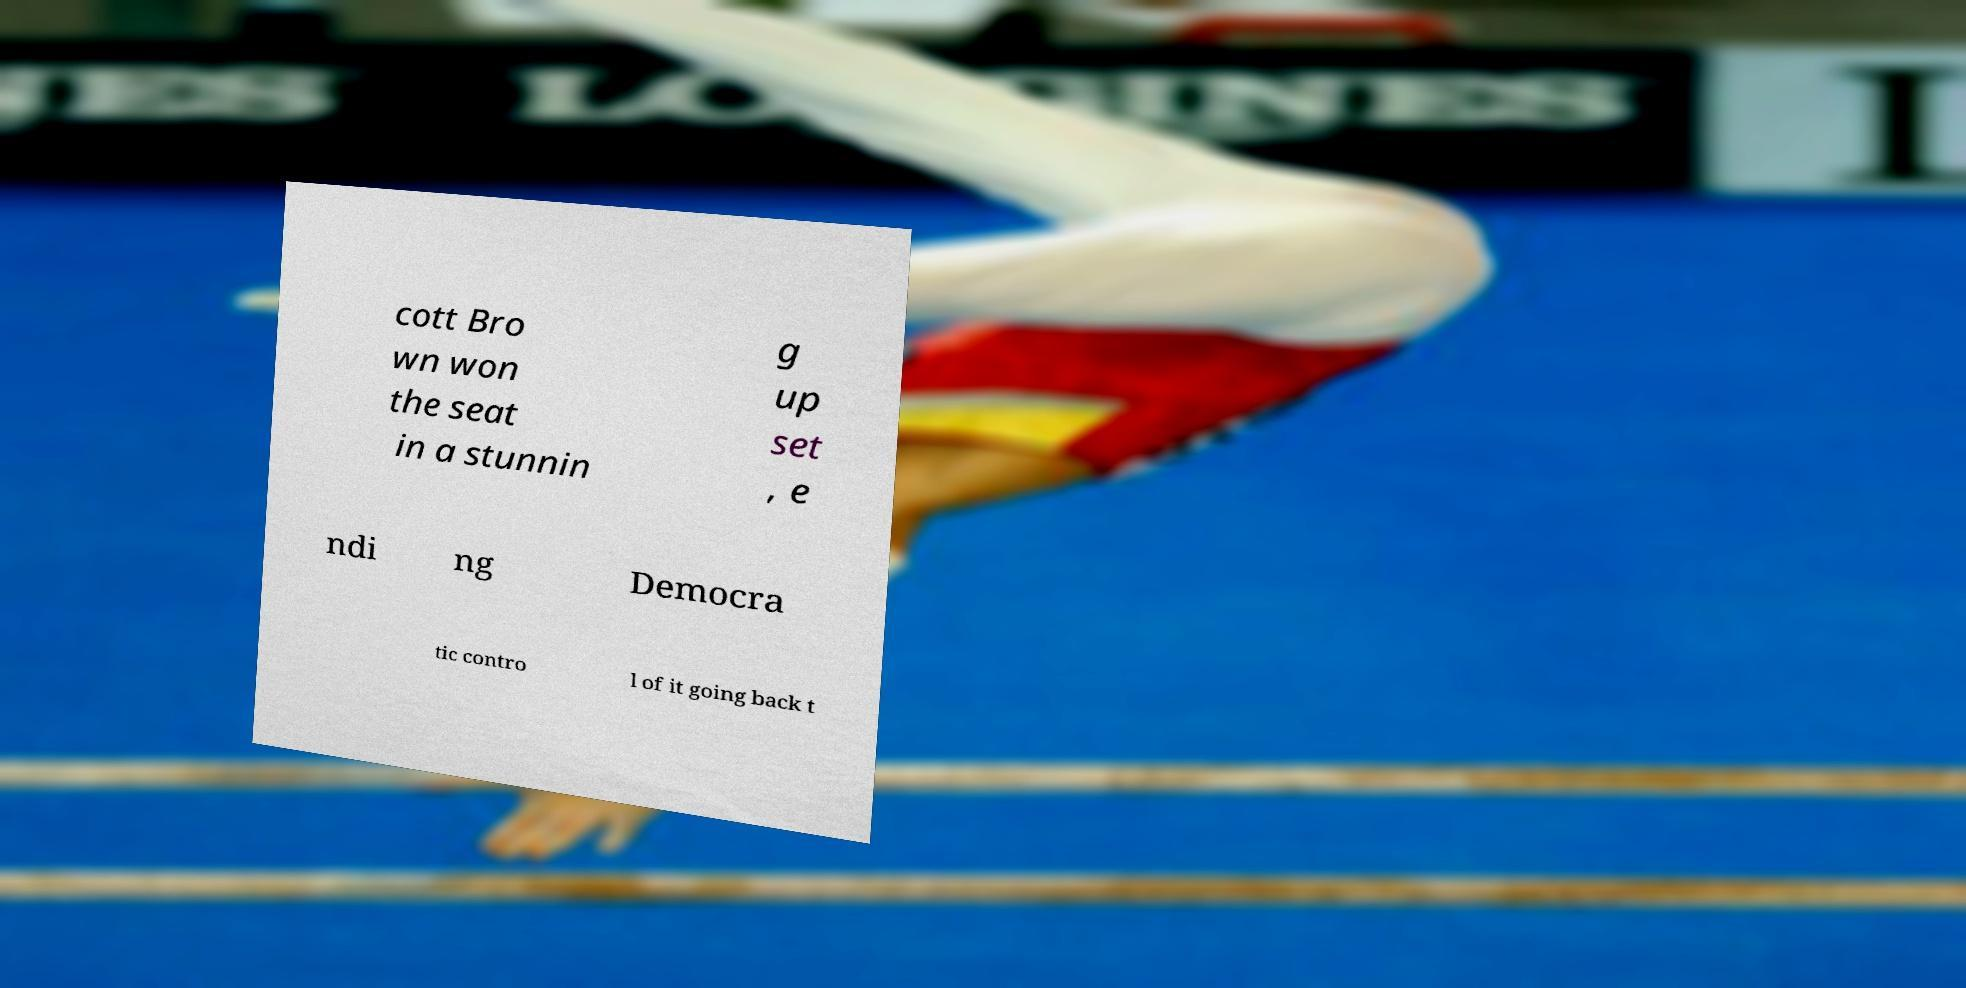What messages or text are displayed in this image? I need them in a readable, typed format. cott Bro wn won the seat in a stunnin g up set , e ndi ng Democra tic contro l of it going back t 